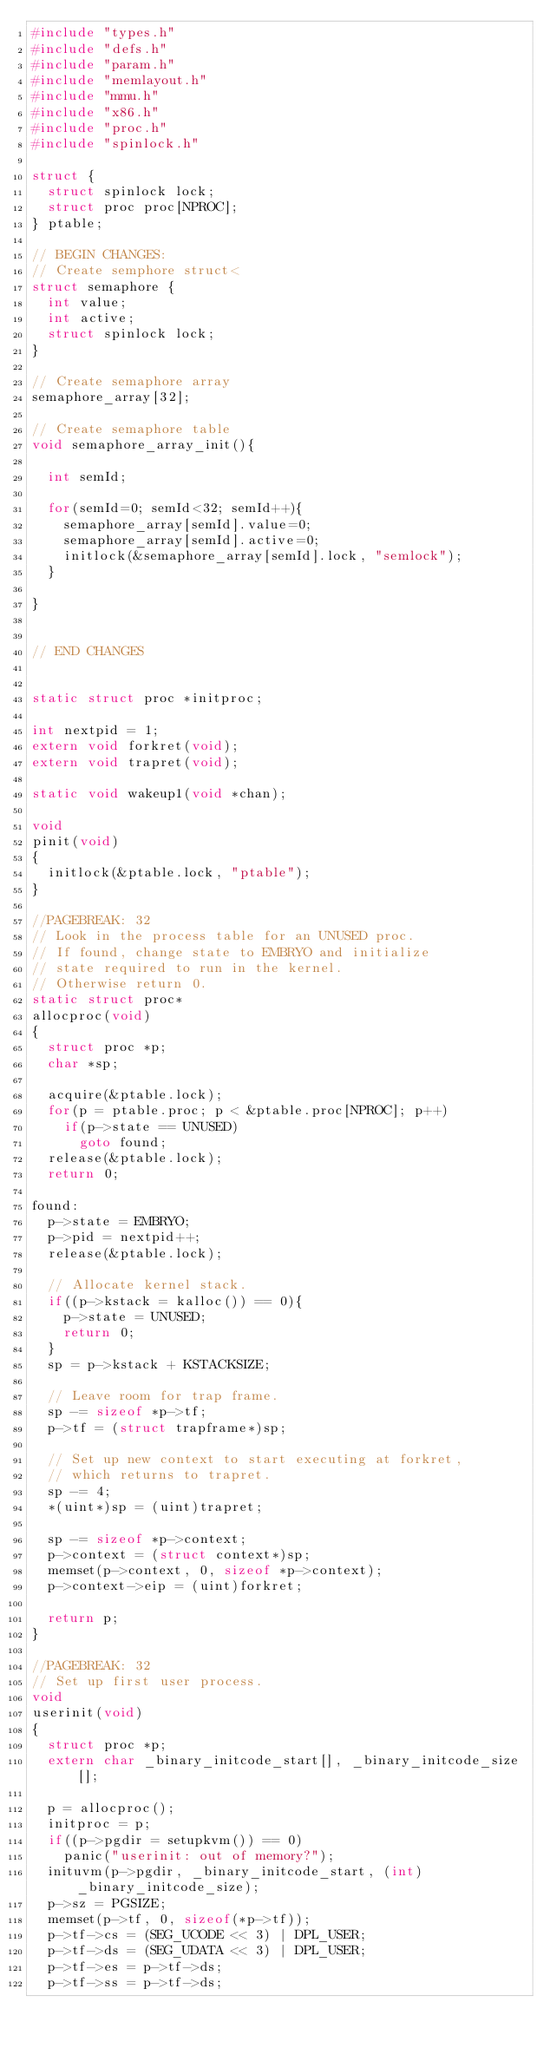Convert code to text. <code><loc_0><loc_0><loc_500><loc_500><_C_>#include "types.h"
#include "defs.h"
#include "param.h"
#include "memlayout.h"
#include "mmu.h"
#include "x86.h"
#include "proc.h"
#include "spinlock.h"

struct {
  struct spinlock lock;
  struct proc proc[NPROC];
} ptable;

// BEGIN CHANGES:
// Create semphore struct<
struct semaphore {
  int value;
  int active;
  struct spinlock lock;
} 

// Create semaphore array
semaphore_array[32];

// Create semaphore table
void semaphore_array_init(){

  int semId;

  for(semId=0; semId<32; semId++){
    semaphore_array[semId].value=0;
    semaphore_array[semId].active=0;
    initlock(&semaphore_array[semId].lock, "semlock");
  }

}


// END CHANGES


static struct proc *initproc;

int nextpid = 1;
extern void forkret(void);
extern void trapret(void);

static void wakeup1(void *chan);

void
pinit(void)
{
  initlock(&ptable.lock, "ptable");
}

//PAGEBREAK: 32
// Look in the process table for an UNUSED proc.
// If found, change state to EMBRYO and initialize
// state required to run in the kernel.
// Otherwise return 0.
static struct proc*
allocproc(void)
{
  struct proc *p;
  char *sp;

  acquire(&ptable.lock);
  for(p = ptable.proc; p < &ptable.proc[NPROC]; p++)
    if(p->state == UNUSED)
      goto found;
  release(&ptable.lock);
  return 0;

found:
  p->state = EMBRYO;
  p->pid = nextpid++;
  release(&ptable.lock);

  // Allocate kernel stack.
  if((p->kstack = kalloc()) == 0){
    p->state = UNUSED;
    return 0;
  }
  sp = p->kstack + KSTACKSIZE;
  
  // Leave room for trap frame.
  sp -= sizeof *p->tf;
  p->tf = (struct trapframe*)sp;
  
  // Set up new context to start executing at forkret,
  // which returns to trapret.
  sp -= 4;
  *(uint*)sp = (uint)trapret;

  sp -= sizeof *p->context;
  p->context = (struct context*)sp;
  memset(p->context, 0, sizeof *p->context);
  p->context->eip = (uint)forkret;

  return p;
}

//PAGEBREAK: 32
// Set up first user process.
void
userinit(void)
{
  struct proc *p;
  extern char _binary_initcode_start[], _binary_initcode_size[];
  
  p = allocproc();
  initproc = p;
  if((p->pgdir = setupkvm()) == 0)
    panic("userinit: out of memory?");
  inituvm(p->pgdir, _binary_initcode_start, (int)_binary_initcode_size);
  p->sz = PGSIZE;
  memset(p->tf, 0, sizeof(*p->tf));
  p->tf->cs = (SEG_UCODE << 3) | DPL_USER;
  p->tf->ds = (SEG_UDATA << 3) | DPL_USER;
  p->tf->es = p->tf->ds;
  p->tf->ss = p->tf->ds;</code> 